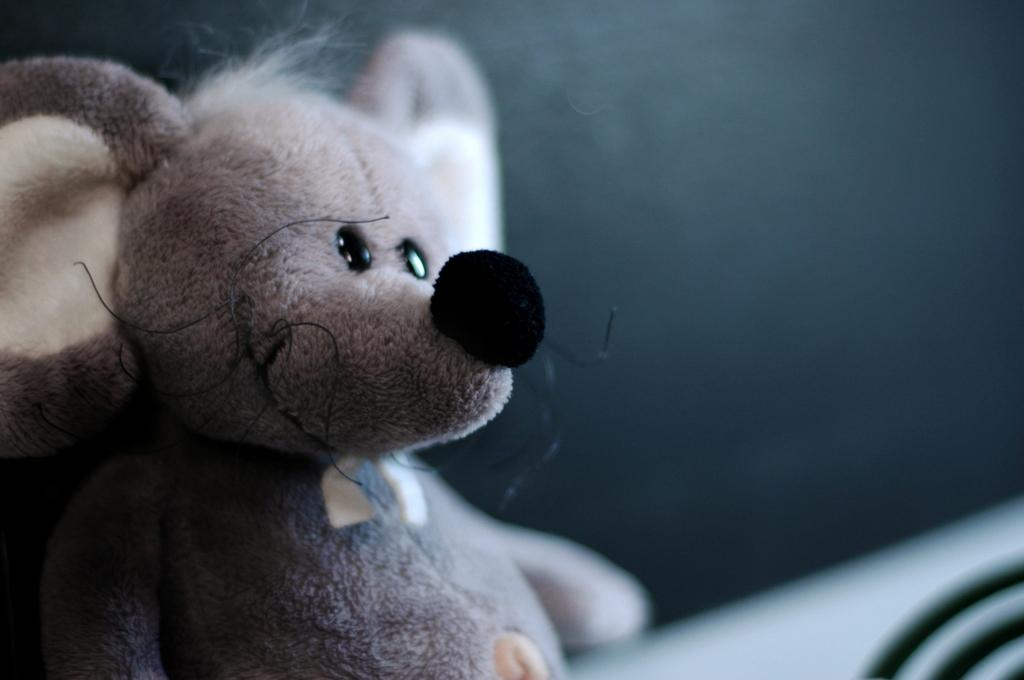What is the main subject of the image? There is a doll in the image. What type of mark can be seen on the moon in the image? There is no moon present in the image; it only features a doll. How does the doll pull a cart in the image? The doll does not pull a cart in the image; there is no cart or any indication of movement. 